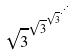<formula> <loc_0><loc_0><loc_500><loc_500>\sqrt { 3 } ^ { \sqrt { 3 } ^ { \sqrt { 3 } ^ { \cdot ^ { \cdot ^ { \cdot } } } } }</formula> 